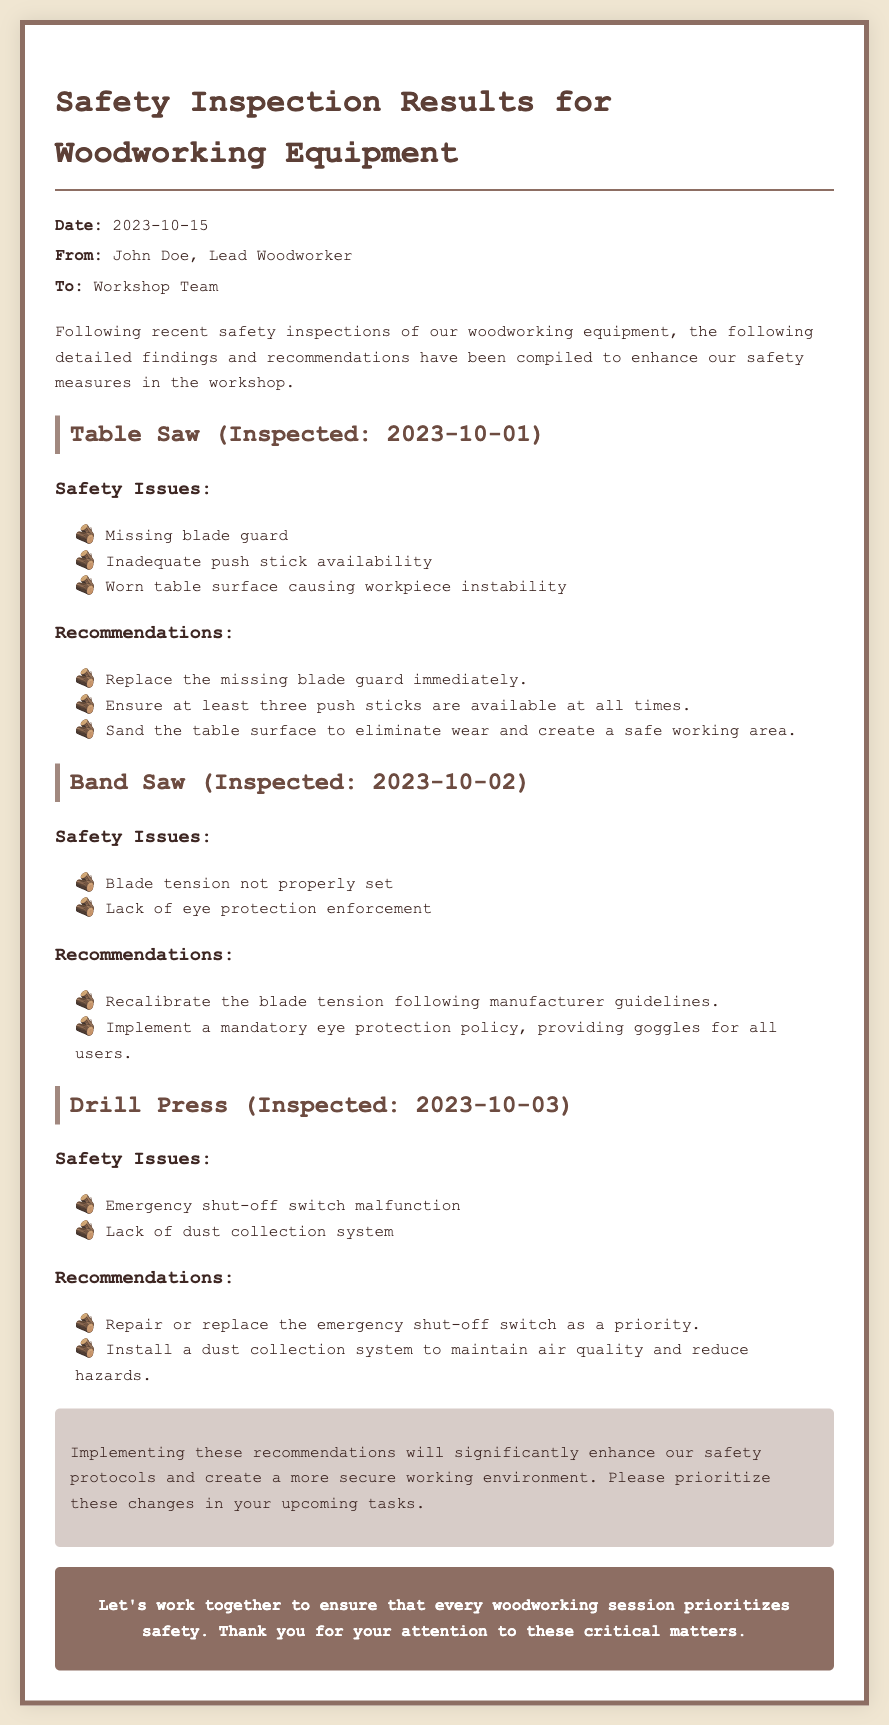what is the date of the inspection memo? The date of the memo is mentioned in the header section, which is 2023-10-15.
Answer: 2023-10-15 who is the author of the memo? The author of the memo, as stated in the header, is John Doe, Lead Woodworker.
Answer: John Doe, Lead Woodworker what equipment was inspected on October 2, 2023? The equipment inspected on this date is specifically stated in the section title for the Band Saw.
Answer: Band Saw how many push sticks should be available at all times according to the recommendations? The recommendation section for the Table Saw clearly states that at least three push sticks should be available.
Answer: three what safety issue was identified with the Drill Press? The safety issue identified is explicitly stated in the section for the Drill Press, which is the malfunction of the emergency shut-off switch.
Answer: Emergency shut-off switch malfunction what is one of the recommendations for improving eye safety? The recommendations section for the Band Saw includes a mandatory eye protection policy as a measure for improving eye safety.
Answer: Mandatory eye protection policy who should prioritize the recommended changes? The concluding section directs the Workshop Team to prioritize these changes in their upcoming tasks.
Answer: Workshop Team what is a unique feature of the document? The memo includes a call-to-action section, which is geared towards encouraging collective responsibility for safety.
Answer: Call-to-action section 